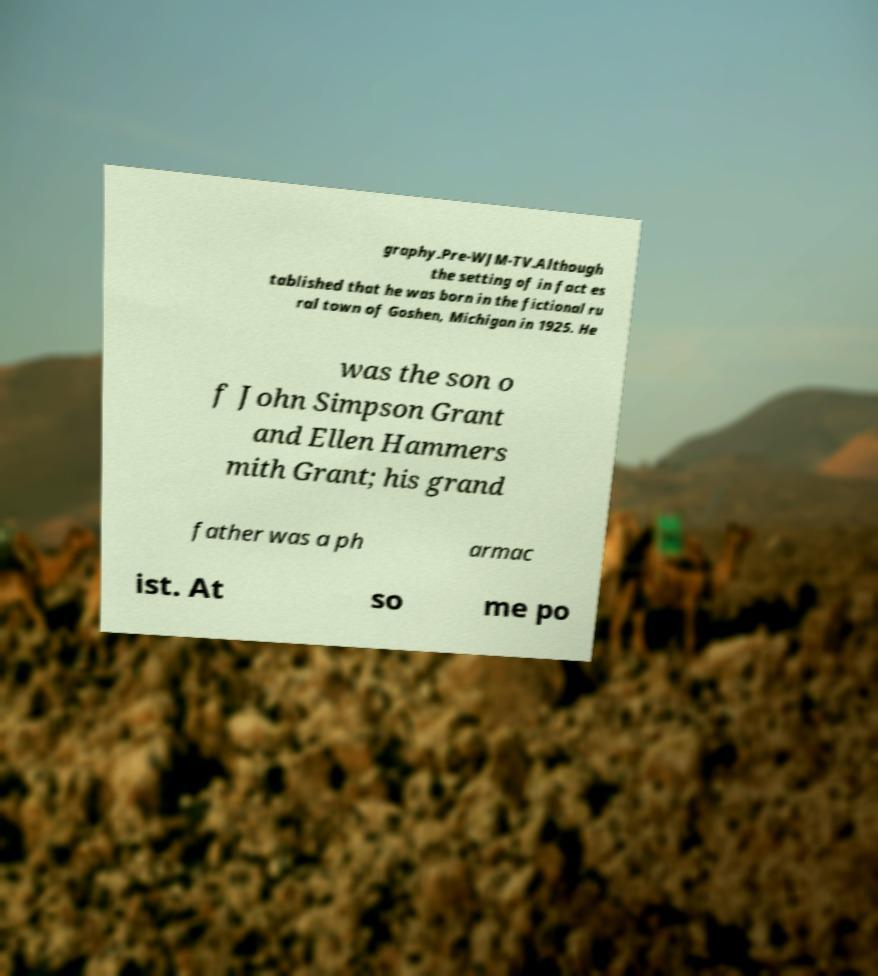Can you accurately transcribe the text from the provided image for me? graphy.Pre-WJM-TV.Although the setting of in fact es tablished that he was born in the fictional ru ral town of Goshen, Michigan in 1925. He was the son o f John Simpson Grant and Ellen Hammers mith Grant; his grand father was a ph armac ist. At so me po 